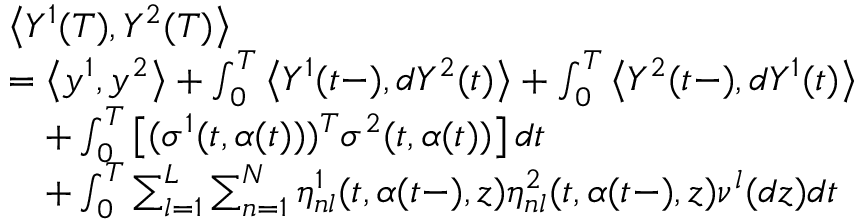<formula> <loc_0><loc_0><loc_500><loc_500>\begin{array} { r l } & { \left \langle Y ^ { 1 } ( T ) , Y ^ { 2 } ( T ) \right \rangle } \\ & { = \left \langle y ^ { 1 } , y ^ { 2 } \right \rangle + \int _ { 0 } ^ { T } \left \langle Y ^ { 1 } ( t - ) , d Y ^ { 2 } ( t ) \right \rangle + \int _ { 0 } ^ { T } \left \langle Y ^ { 2 } ( t - ) , d Y ^ { 1 } ( t ) \right \rangle } \\ & { \quad + \int _ { 0 } ^ { T } \left [ ( \sigma ^ { 1 } ( t , \alpha ( t ) ) ) ^ { T } \sigma ^ { 2 } ( t , \alpha ( t ) ) \right ] d t } \\ & { \quad + \int _ { 0 } ^ { T } \sum _ { l = 1 } ^ { L } \sum _ { n = 1 } ^ { N } \eta _ { n l } ^ { 1 } ( t , \alpha ( t - ) , z ) \eta _ { n l } ^ { 2 } ( t , \alpha ( t - ) , z ) \nu ^ { l } ( d z ) d t } \end{array}</formula> 